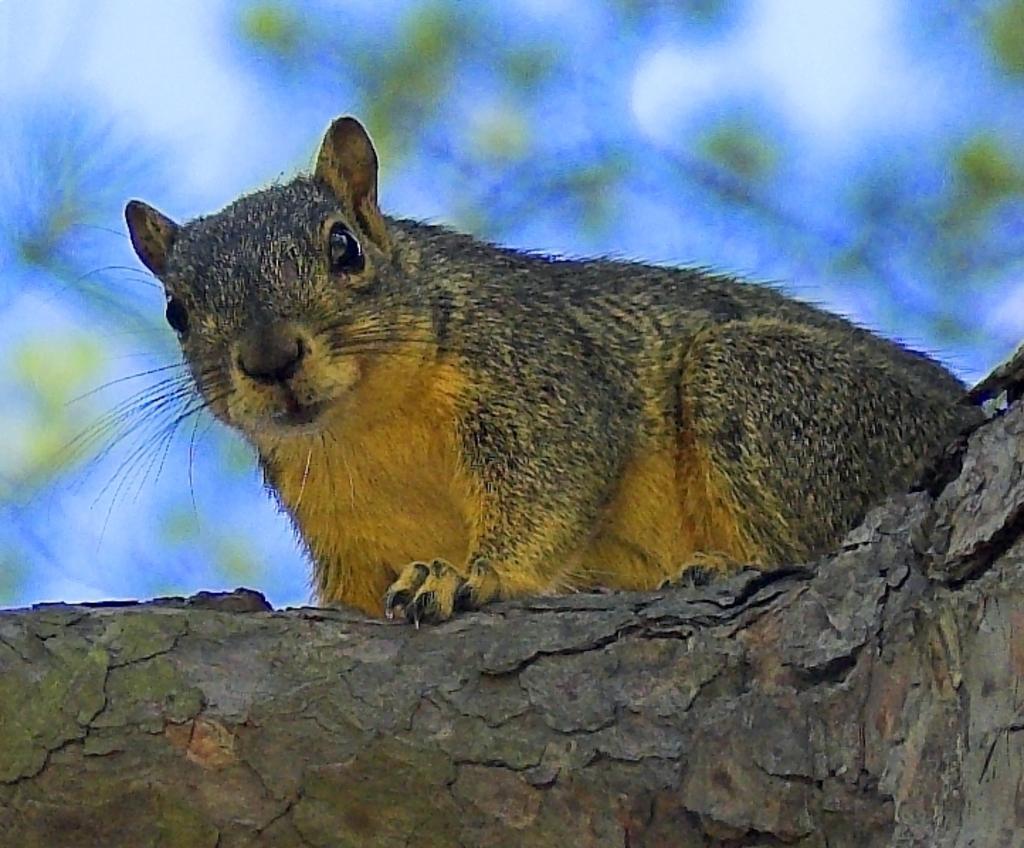Can you describe this image briefly? In this picture we can observe squirrel which is in yellow and grey color. This squirrel is on the branch of a tree. In the background we can observe sky. 